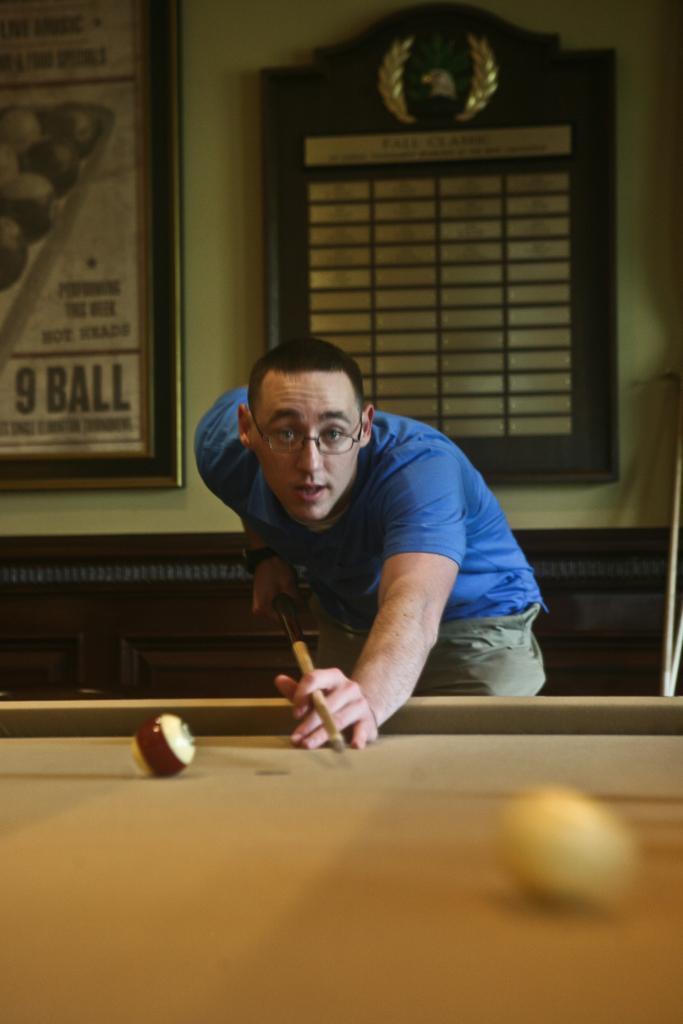Please provide a concise description of this image. A man is hitting a ball on a billiards table. 